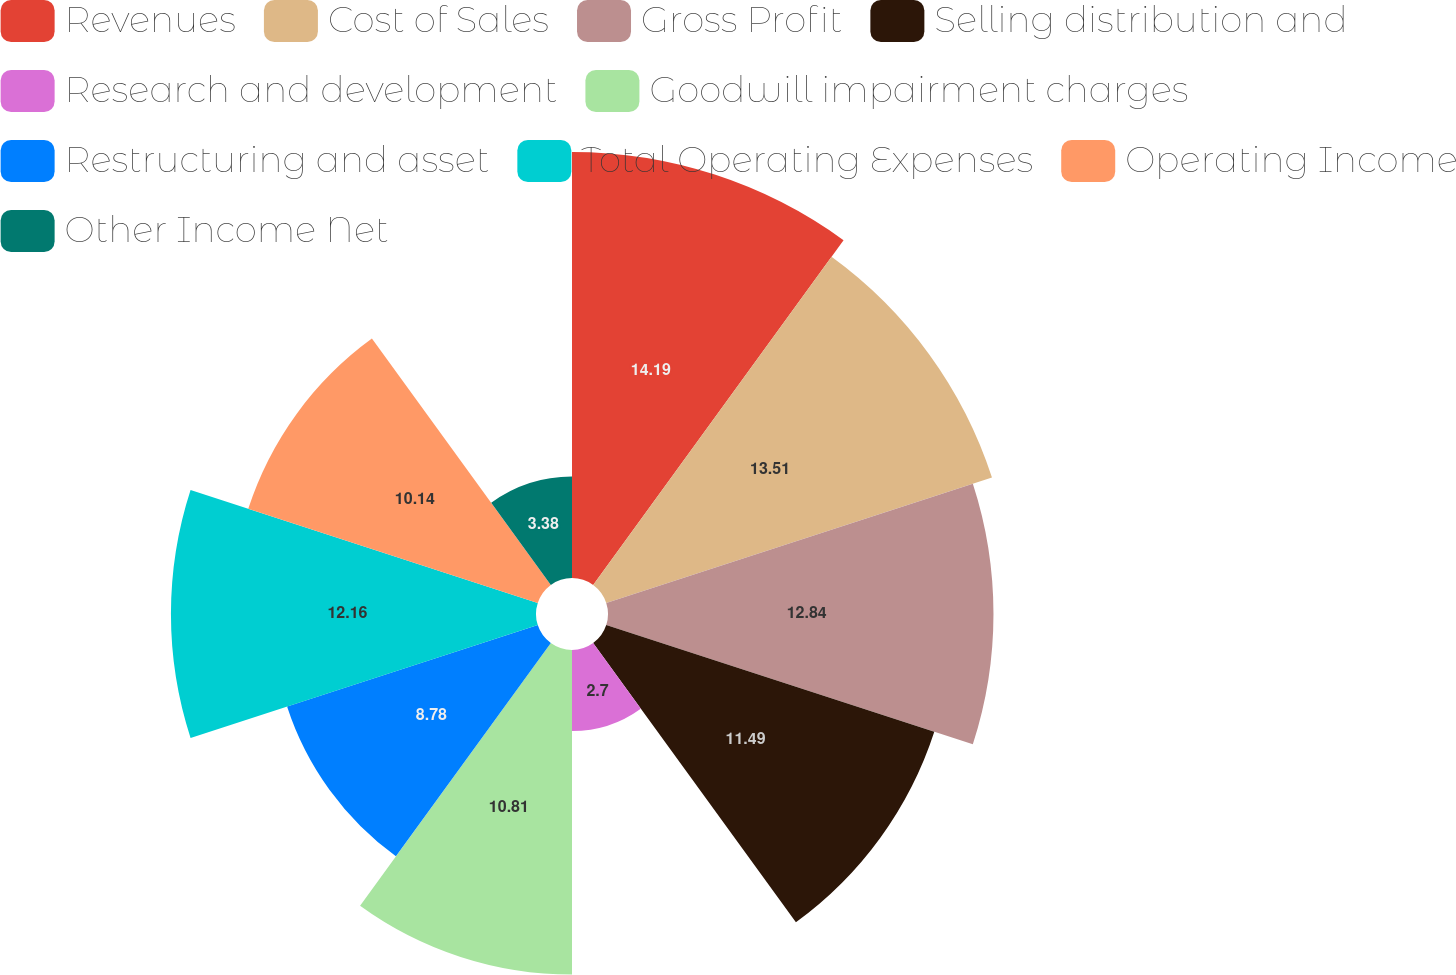<chart> <loc_0><loc_0><loc_500><loc_500><pie_chart><fcel>Revenues<fcel>Cost of Sales<fcel>Gross Profit<fcel>Selling distribution and<fcel>Research and development<fcel>Goodwill impairment charges<fcel>Restructuring and asset<fcel>Total Operating Expenses<fcel>Operating Income<fcel>Other Income Net<nl><fcel>14.19%<fcel>13.51%<fcel>12.84%<fcel>11.49%<fcel>2.7%<fcel>10.81%<fcel>8.78%<fcel>12.16%<fcel>10.14%<fcel>3.38%<nl></chart> 